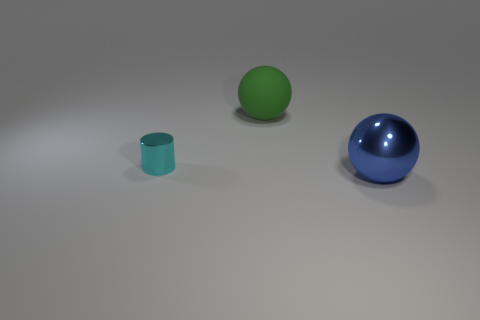Add 2 blue metal things. How many objects exist? 5 Subtract all spheres. How many objects are left? 1 Add 1 large yellow shiny cylinders. How many large yellow shiny cylinders exist? 1 Subtract 0 green cubes. How many objects are left? 3 Subtract all large red metallic blocks. Subtract all big blue things. How many objects are left? 2 Add 3 big rubber things. How many big rubber things are left? 4 